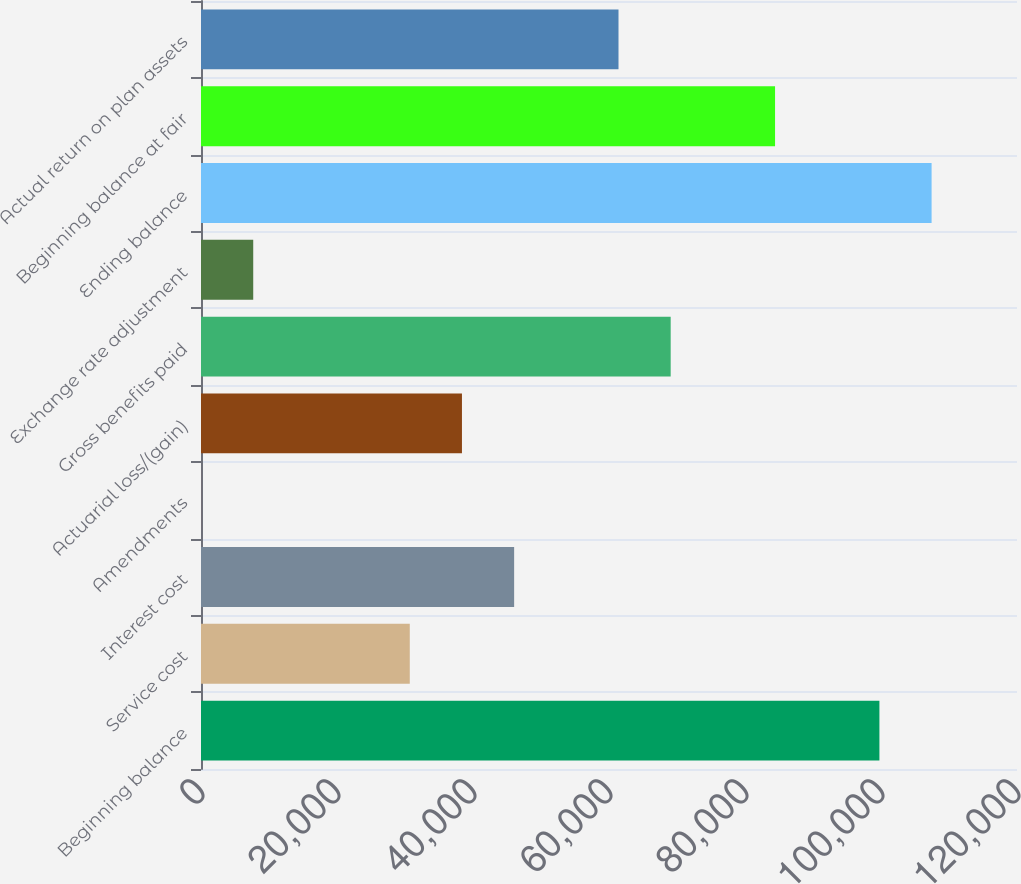<chart> <loc_0><loc_0><loc_500><loc_500><bar_chart><fcel>Beginning balance<fcel>Service cost<fcel>Interest cost<fcel>Amendments<fcel>Actuarial loss/(gain)<fcel>Gross benefits paid<fcel>Exchange rate adjustment<fcel>Ending balance<fcel>Beginning balance at fair<fcel>Actual return on plan assets<nl><fcel>99766.7<fcel>30701.6<fcel>46049.4<fcel>6<fcel>38375.5<fcel>69071.1<fcel>7679.9<fcel>107441<fcel>84418.9<fcel>61397.2<nl></chart> 